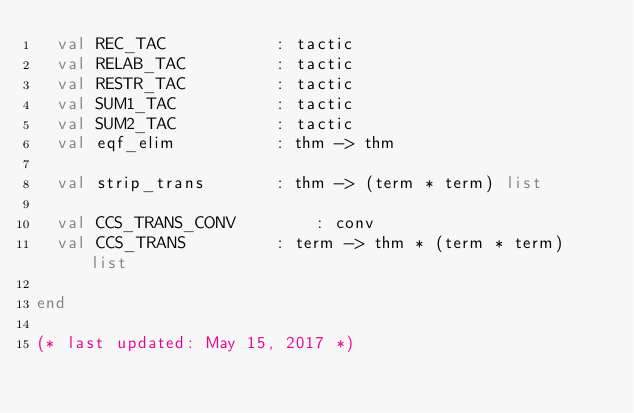<code> <loc_0><loc_0><loc_500><loc_500><_SML_>  val REC_TAC			: tactic
  val RELAB_TAC			: tactic
  val RESTR_TAC			: tactic
  val SUM1_TAC			: tactic
  val SUM2_TAC			: tactic
  val eqf_elim			: thm -> thm

  val strip_trans		: thm -> (term * term) list

  val CCS_TRANS_CONV		: conv
  val CCS_TRANS			: term -> thm * (term * term) list

end

(* last updated: May 15, 2017 *)
</code> 